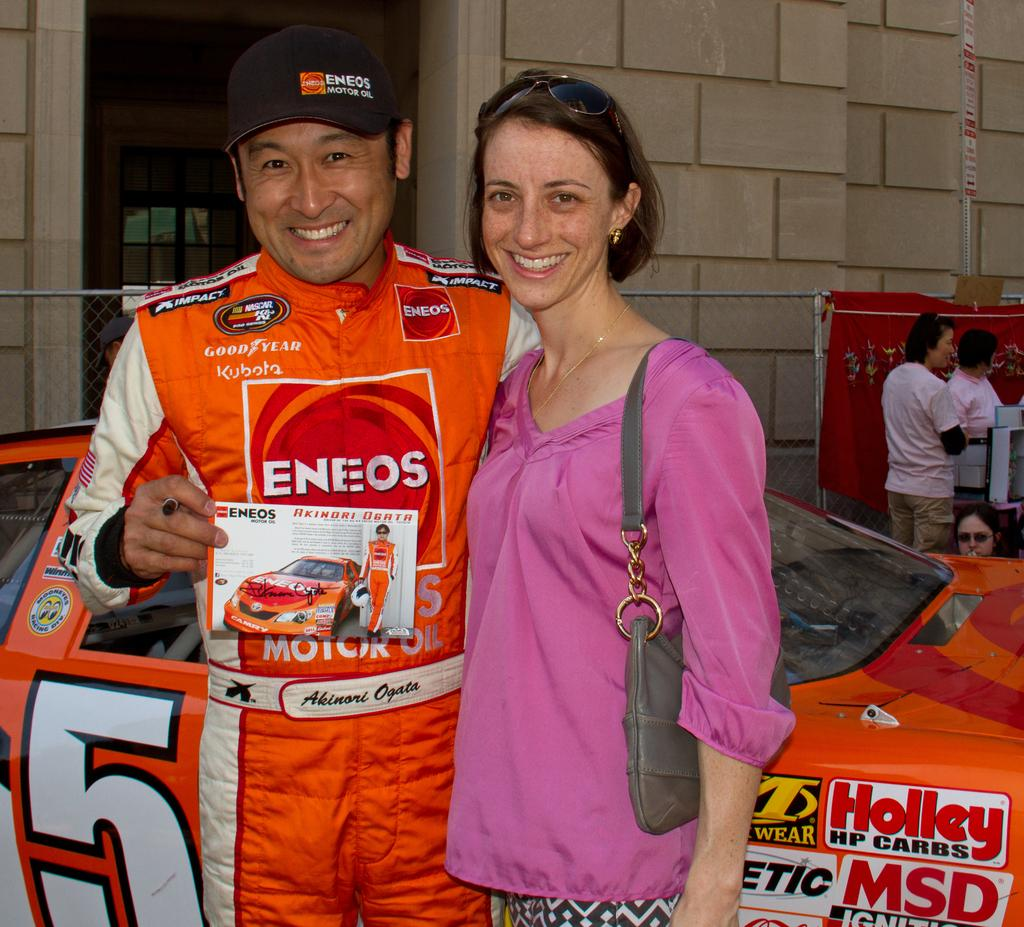<image>
Share a concise interpretation of the image provided. Akinori Ogata in a racing uniform holding a signed flyer for Eneos motor oil 